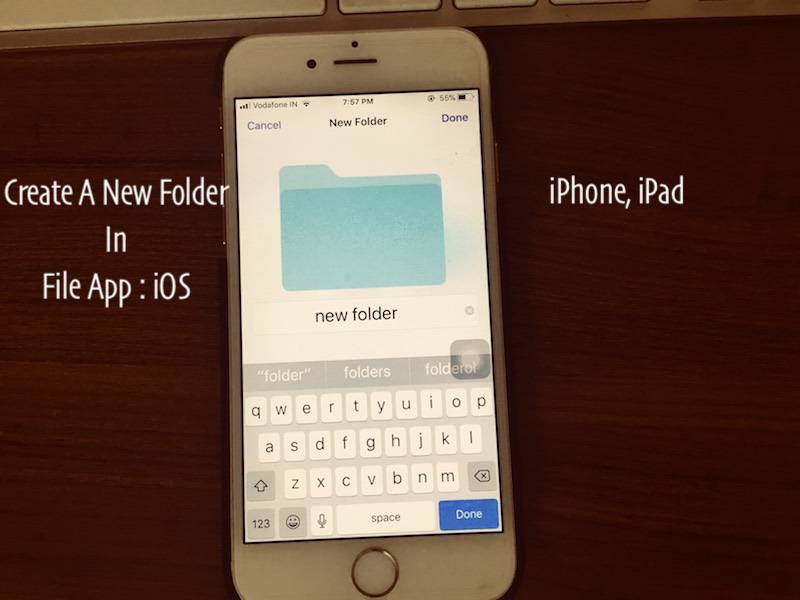Imagine the user is planning a big project; how could the folder structure assist them in their project management tonight? If the user is planning a big project, creating a well-organized folder structure is a critical first step for effective project management. By categorizing files into specific folders, they can segregate different aspects of the project, such as research material, drafts, finalized documents, and related correspondence. This systematic approach allows for better focus and quicker access to needed materials. Additionally, grouping files can help in setting clear milestones and deadlines, enabling the user to track progress more efficiently. As it is evening, this organization can set the tone for a productive start the next morning and help the user feel more prepared and less overwhelmed. Can you create an imaginative scenario where organizing files becomes a step in an adventurous plan? Absolutely! Imagine the user is a secret agent preparing for an undercover mission. Organizing files into new folders is akin to assembling their mission dossier. Each folder contains crucial intelligence: one with blueprints of the target location, another with profiles of key figures, and yet another with escape plans and contingency protocols. As they meticulously organize this information, the suspense builds. They know that tonight's preparation is essential for tomorrow's success. The ticking clock and their device's dwindling battery add to the tension, underscoring the importance of completing these preparations swiftly to ensure every detail is in place before the mission begins at dawn. 